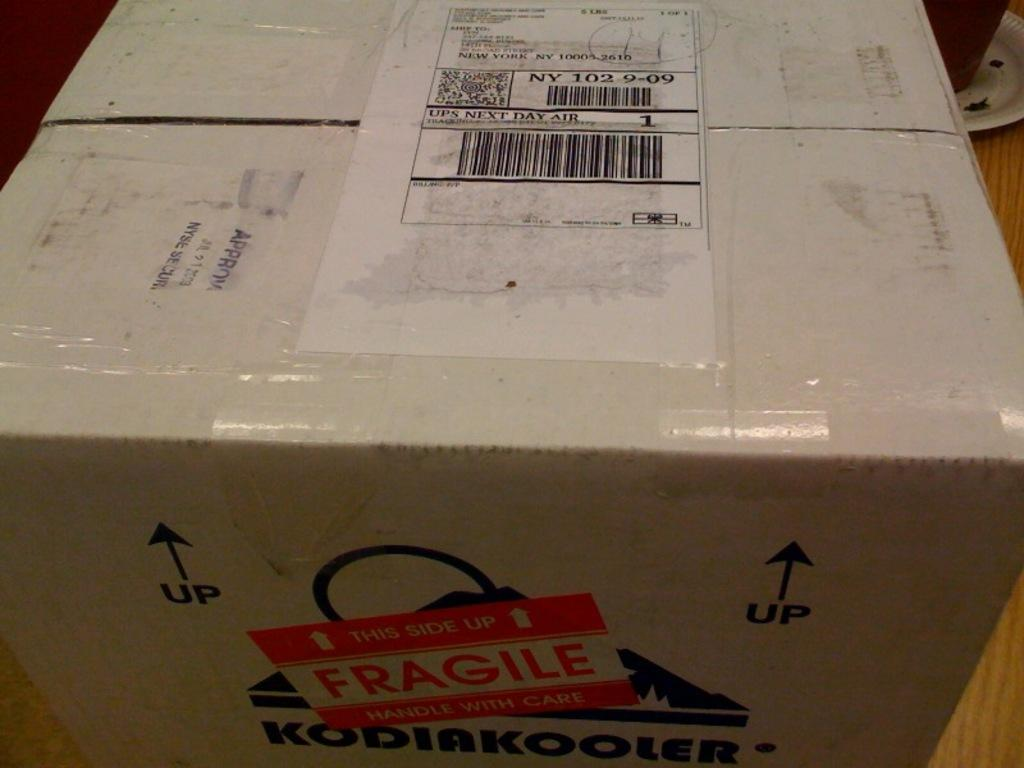<image>
Render a clear and concise summary of the photo. A large cardboard box has a fragile sticker on one side. 